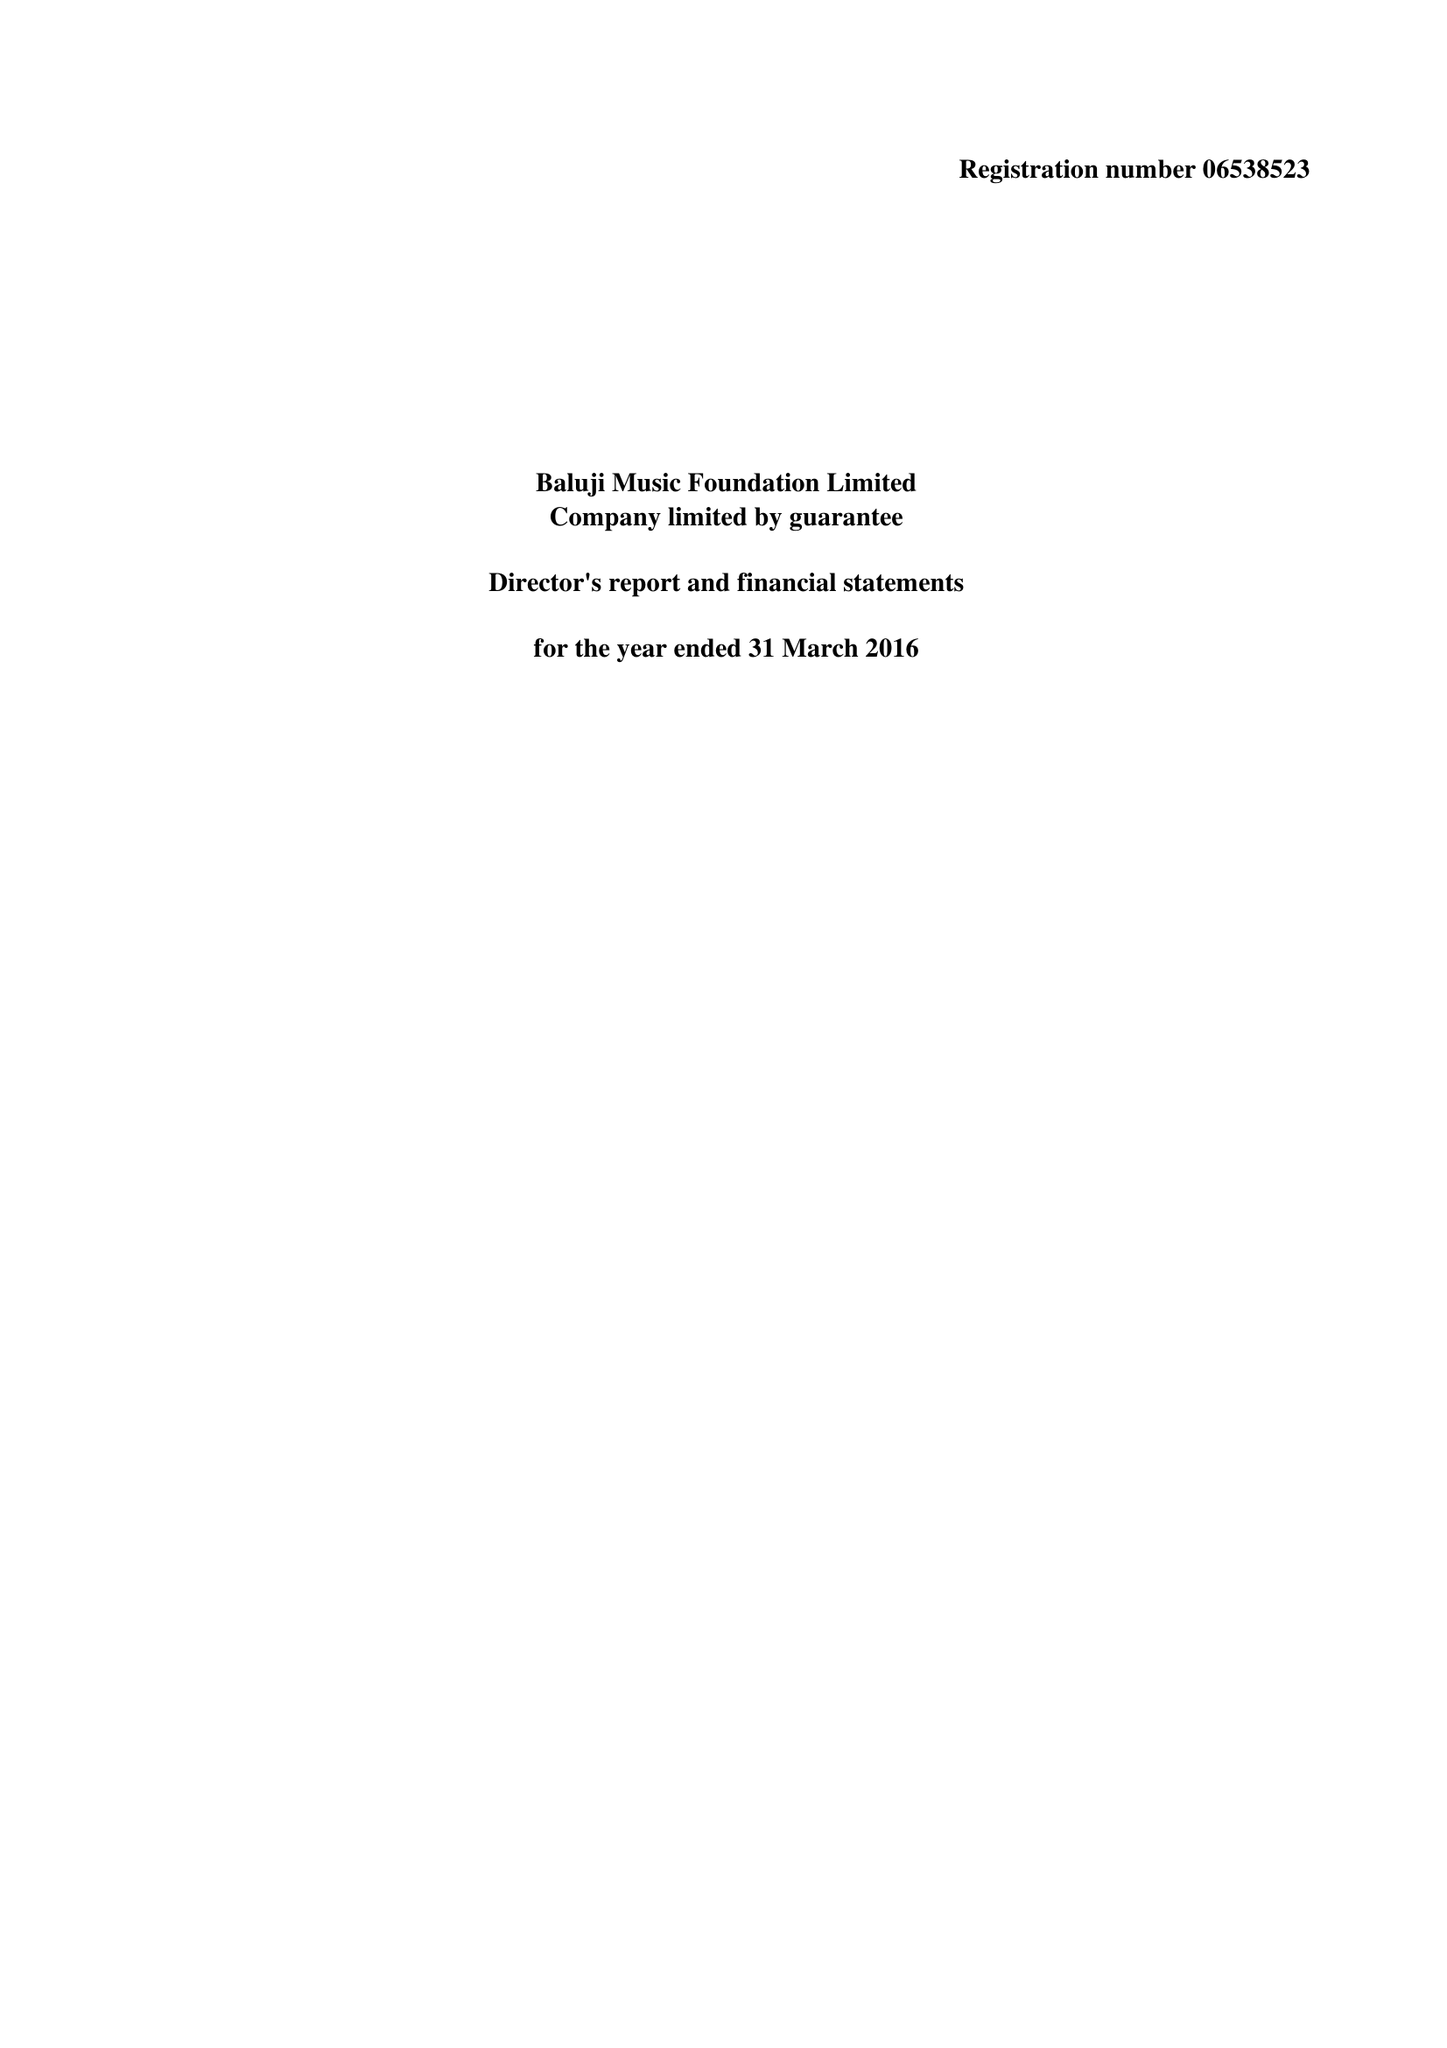What is the value for the charity_name?
Answer the question using a single word or phrase. Baluji Music Foundation Ltd. 